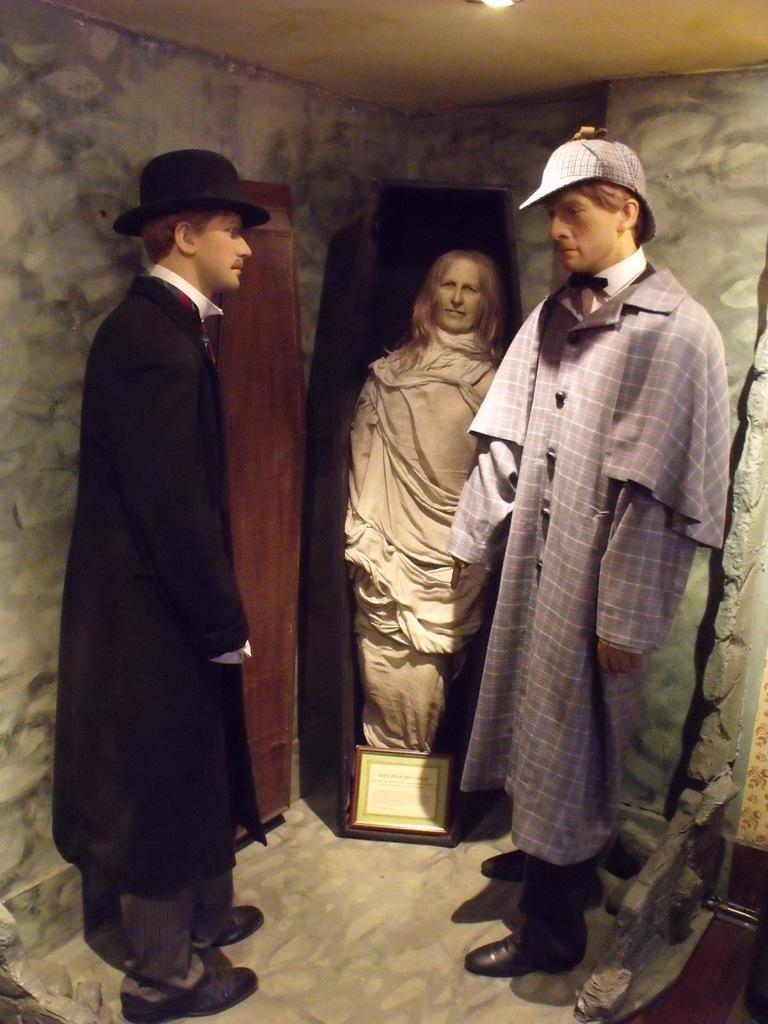What type of objects can be seen in the image? There are statues in the image. What architectural elements are present in the image? There are walls and a roof with light in the image. What type of glue is being used to hold the table together in the image? There is no table present in the image, so it is not possible to determine what type of glue might be used. 